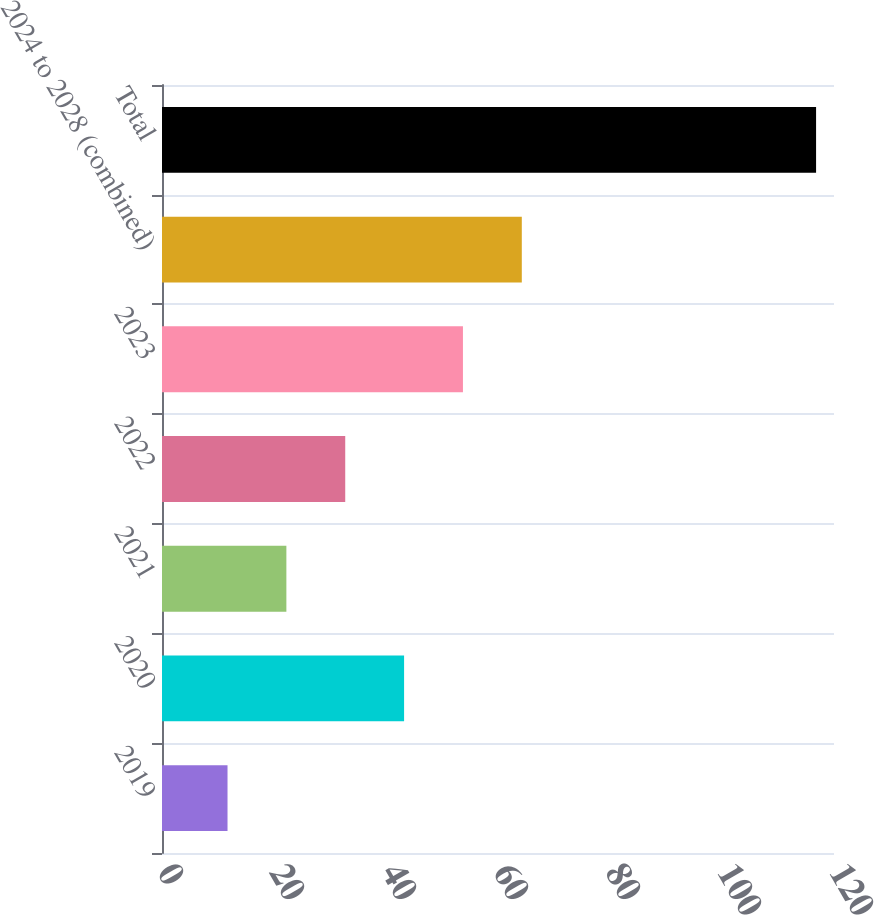<chart> <loc_0><loc_0><loc_500><loc_500><bar_chart><fcel>2019<fcel>2020<fcel>2021<fcel>2022<fcel>2023<fcel>2024 to 2028 (combined)<fcel>Total<nl><fcel>11.7<fcel>43.23<fcel>22.21<fcel>32.72<fcel>53.74<fcel>64.25<fcel>116.8<nl></chart> 